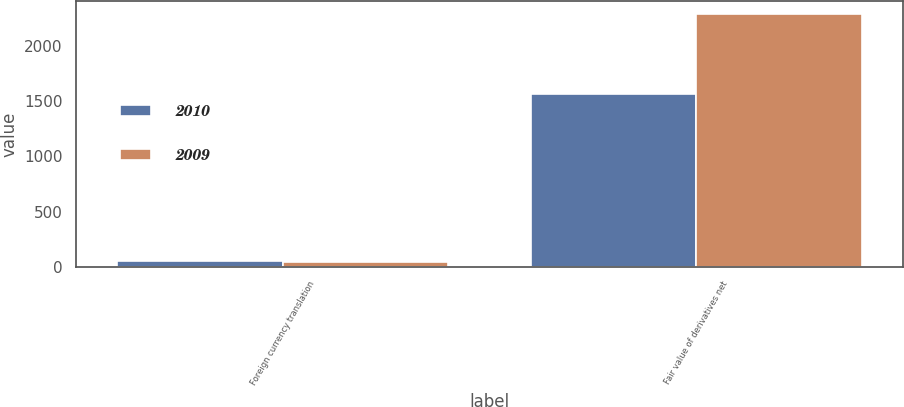Convert chart to OTSL. <chart><loc_0><loc_0><loc_500><loc_500><stacked_bar_chart><ecel><fcel>Foreign currency translation<fcel>Fair value of derivatives net<nl><fcel>2010<fcel>51<fcel>1570<nl><fcel>2009<fcel>45<fcel>2294<nl></chart> 